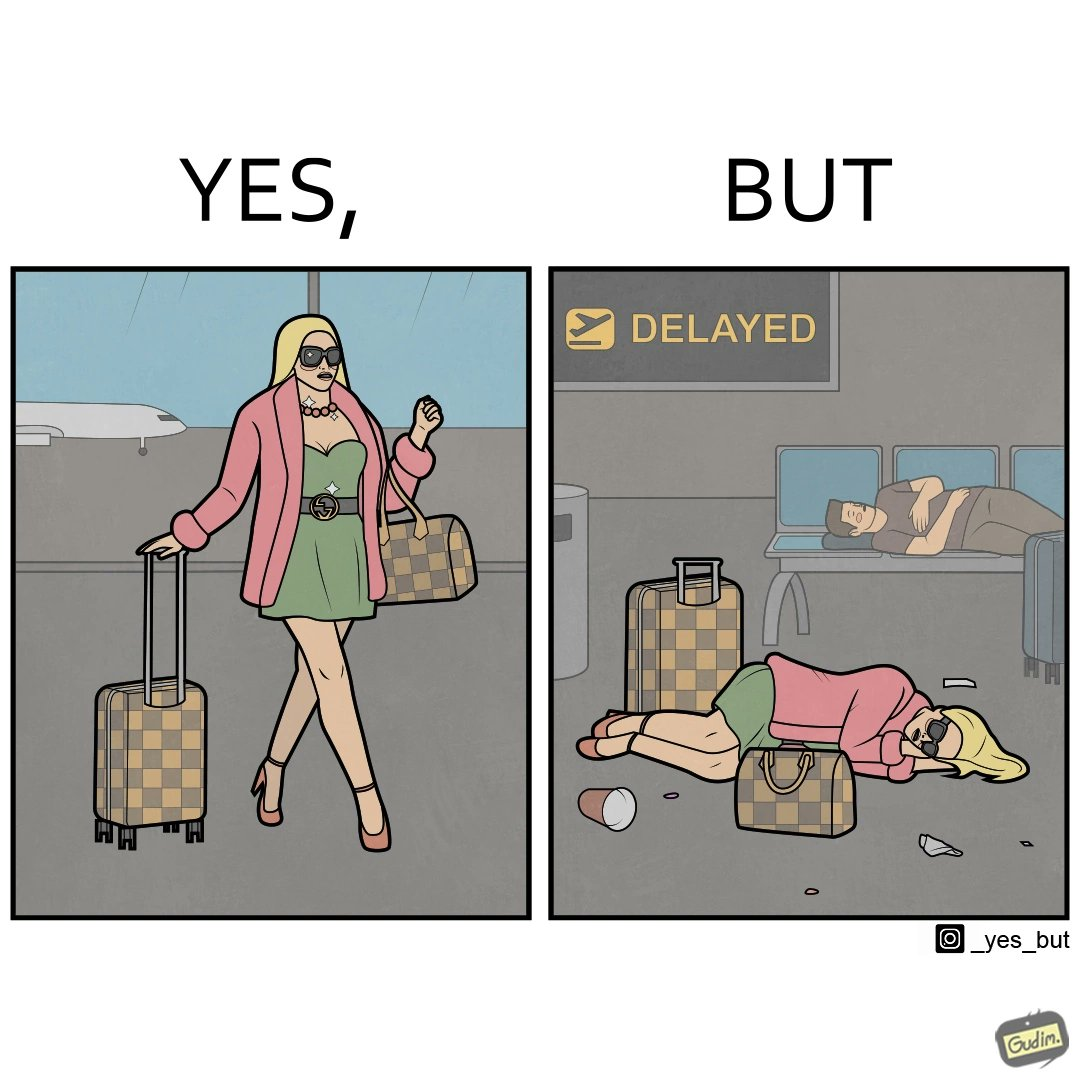Is this image satirical or non-satirical? Yes, this image is satirical. 